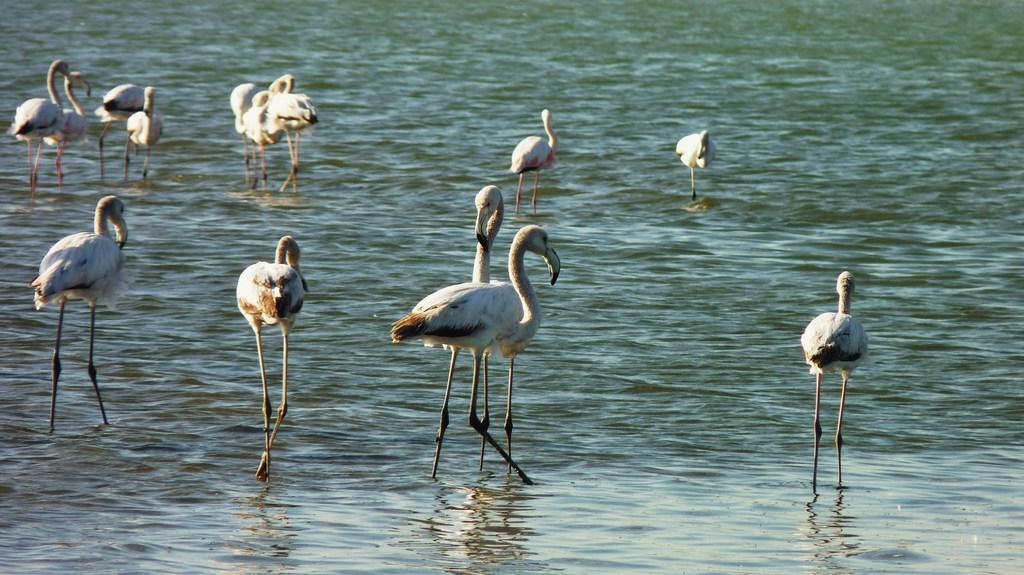What type of animals are in the image? There is a group of birds in the image. Can you identify the specific species of the birds? Yes, the birds are greater flamingos. Where are the birds located in the image? The birds are in the water. What type of yarn is being used by the birds in the image? There is no yarn present in the image. The image features a group of greater flamingos in the water. 